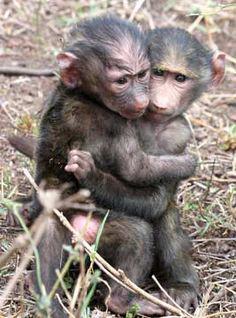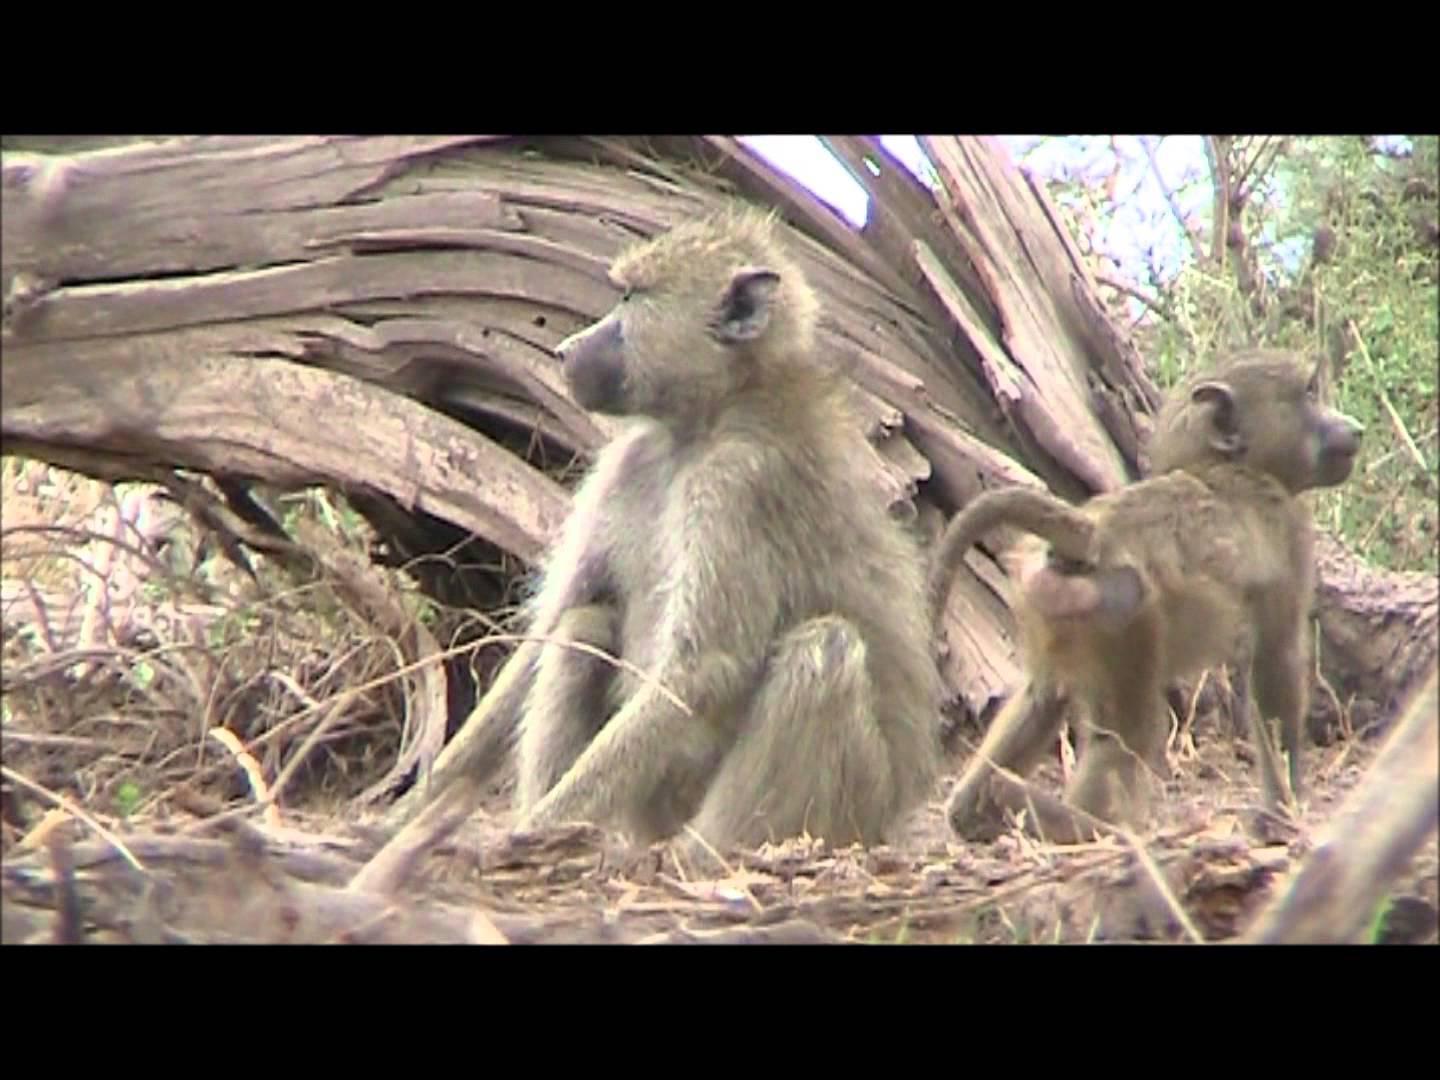The first image is the image on the left, the second image is the image on the right. Assess this claim about the two images: "In one of the images monkeys are in a tree.". Correct or not? Answer yes or no. No. The first image is the image on the left, the second image is the image on the right. Examine the images to the left and right. Is the description "There are no more than four monkeys." accurate? Answer yes or no. Yes. 